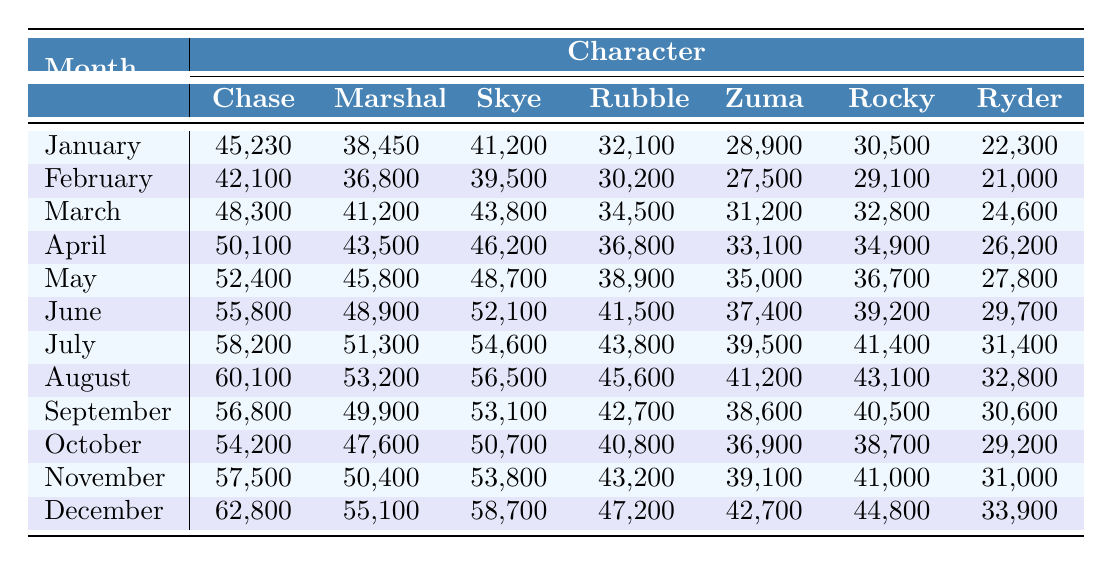How many Chase toys were sold in December? Referring to the December row, Chase sold 62,800 toys.
Answer: 62,800 Which character had the highest sales in August? In August, Skye had the highest sales with 56,500 toys sold.
Answer: Skye What is the total number of toys sold for Ryder from January to March? Adding Ryder's sales from January (22,300), February (21,000), and March (24,600) gives 22,300 + 21,000 + 24,600 = 67,900.
Answer: 67,900 Did Marshall's sales increase consistently every month? No, Marshall's sales decreased from October (47,600) to November (50,400) and then increased again in December (55,100).
Answer: No What was the average sales figure for Rubble over the entire year? To find the average, sum Rubble’s sales for each month: (32,100 + 30,200 + 34,500 + 36,800 + 38,900 + 41,500 + 43,800 + 45,600 + 42,700 + 40,800 + 43,200 + 47,200) = 482,500, and divide by 12 months: 482,500 / 12 = 40,208.33.
Answer: 40,208 Which month saw the lowest sales for Zuma? The lowest sales for Zuma occurred in February with 27,500 toys sold.
Answer: February What character consistently sold fewer toys than Chase for the entire year? Throughout the year, Ryder consistently sold fewer toys than Chase in all the months.
Answer: Ryder What is the difference in sales between the highest and lowest months for Skye? The highest sales for Skye were in December (58,700) and the lowest in February (39,500), so the difference is 58,700 - 39,500 = 19,200.
Answer: 19,200 Was there any month where Rocky's sales were above 40,000? Yes, Rocky had sales above 40,000 in every month except January (30,500), February (29,100), and December (44,800).
Answer: Yes In which month did Chase have its lowest sales compared to other months? Chase had its lowest sales in February with 42,100 toys sold.
Answer: February Calculate the total sales for Marshall from May to August. Marshall's sales from May (45,800), June (48,900), July (51,300), and August (53,200) add up to: 45,800 + 48,900 + 51,300 + 53,200 = 199,200.
Answer: 199,200 